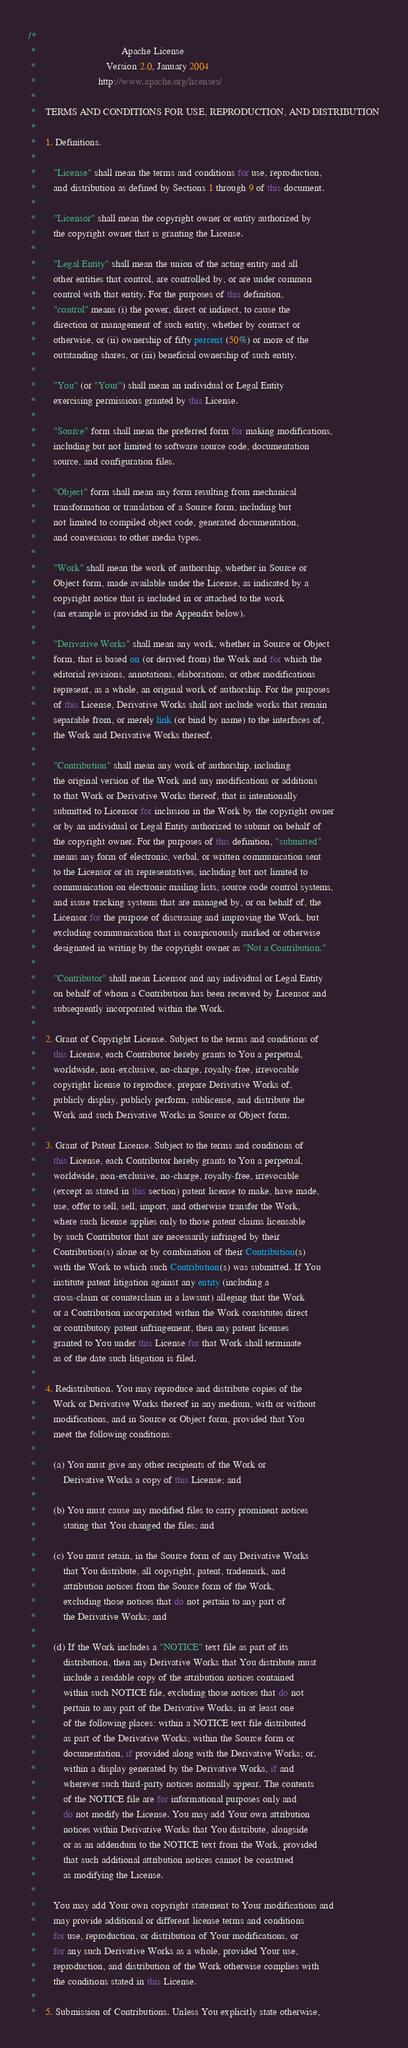<code> <loc_0><loc_0><loc_500><loc_500><_Java_>/*
 *                                  Apache License
 *                            Version 2.0, January 2004
 *                         http://www.apache.org/licenses/
 *
 *    TERMS AND CONDITIONS FOR USE, REPRODUCTION, AND DISTRIBUTION
 *
 *    1. Definitions.
 *
 *       "License" shall mean the terms and conditions for use, reproduction,
 *       and distribution as defined by Sections 1 through 9 of this document.
 *
 *       "Licensor" shall mean the copyright owner or entity authorized by
 *       the copyright owner that is granting the License.
 *
 *       "Legal Entity" shall mean the union of the acting entity and all
 *       other entities that control, are controlled by, or are under common
 *       control with that entity. For the purposes of this definition,
 *       "control" means (i) the power, direct or indirect, to cause the
 *       direction or management of such entity, whether by contract or
 *       otherwise, or (ii) ownership of fifty percent (50%) or more of the
 *       outstanding shares, or (iii) beneficial ownership of such entity.
 *
 *       "You" (or "Your") shall mean an individual or Legal Entity
 *       exercising permissions granted by this License.
 *
 *       "Source" form shall mean the preferred form for making modifications,
 *       including but not limited to software source code, documentation
 *       source, and configuration files.
 *
 *       "Object" form shall mean any form resulting from mechanical
 *       transformation or translation of a Source form, including but
 *       not limited to compiled object code, generated documentation,
 *       and conversions to other media types.
 *
 *       "Work" shall mean the work of authorship, whether in Source or
 *       Object form, made available under the License, as indicated by a
 *       copyright notice that is included in or attached to the work
 *       (an example is provided in the Appendix below).
 *
 *       "Derivative Works" shall mean any work, whether in Source or Object
 *       form, that is based on (or derived from) the Work and for which the
 *       editorial revisions, annotations, elaborations, or other modifications
 *       represent, as a whole, an original work of authorship. For the purposes
 *       of this License, Derivative Works shall not include works that remain
 *       separable from, or merely link (or bind by name) to the interfaces of,
 *       the Work and Derivative Works thereof.
 *
 *       "Contribution" shall mean any work of authorship, including
 *       the original version of the Work and any modifications or additions
 *       to that Work or Derivative Works thereof, that is intentionally
 *       submitted to Licensor for inclusion in the Work by the copyright owner
 *       or by an individual or Legal Entity authorized to submit on behalf of
 *       the copyright owner. For the purposes of this definition, "submitted"
 *       means any form of electronic, verbal, or written communication sent
 *       to the Licensor or its representatives, including but not limited to
 *       communication on electronic mailing lists, source code control systems,
 *       and issue tracking systems that are managed by, or on behalf of, the
 *       Licensor for the purpose of discussing and improving the Work, but
 *       excluding communication that is conspicuously marked or otherwise
 *       designated in writing by the copyright owner as "Not a Contribution."
 *
 *       "Contributor" shall mean Licensor and any individual or Legal Entity
 *       on behalf of whom a Contribution has been received by Licensor and
 *       subsequently incorporated within the Work.
 *
 *    2. Grant of Copyright License. Subject to the terms and conditions of
 *       this License, each Contributor hereby grants to You a perpetual,
 *       worldwide, non-exclusive, no-charge, royalty-free, irrevocable
 *       copyright license to reproduce, prepare Derivative Works of,
 *       publicly display, publicly perform, sublicense, and distribute the
 *       Work and such Derivative Works in Source or Object form.
 *
 *    3. Grant of Patent License. Subject to the terms and conditions of
 *       this License, each Contributor hereby grants to You a perpetual,
 *       worldwide, non-exclusive, no-charge, royalty-free, irrevocable
 *       (except as stated in this section) patent license to make, have made,
 *       use, offer to sell, sell, import, and otherwise transfer the Work,
 *       where such license applies only to those patent claims licensable
 *       by such Contributor that are necessarily infringed by their
 *       Contribution(s) alone or by combination of their Contribution(s)
 *       with the Work to which such Contribution(s) was submitted. If You
 *       institute patent litigation against any entity (including a
 *       cross-claim or counterclaim in a lawsuit) alleging that the Work
 *       or a Contribution incorporated within the Work constitutes direct
 *       or contributory patent infringement, then any patent licenses
 *       granted to You under this License for that Work shall terminate
 *       as of the date such litigation is filed.
 *
 *    4. Redistribution. You may reproduce and distribute copies of the
 *       Work or Derivative Works thereof in any medium, with or without
 *       modifications, and in Source or Object form, provided that You
 *       meet the following conditions:
 *
 *       (a) You must give any other recipients of the Work or
 *           Derivative Works a copy of this License; and
 *
 *       (b) You must cause any modified files to carry prominent notices
 *           stating that You changed the files; and
 *
 *       (c) You must retain, in the Source form of any Derivative Works
 *           that You distribute, all copyright, patent, trademark, and
 *           attribution notices from the Source form of the Work,
 *           excluding those notices that do not pertain to any part of
 *           the Derivative Works; and
 *
 *       (d) If the Work includes a "NOTICE" text file as part of its
 *           distribution, then any Derivative Works that You distribute must
 *           include a readable copy of the attribution notices contained
 *           within such NOTICE file, excluding those notices that do not
 *           pertain to any part of the Derivative Works, in at least one
 *           of the following places: within a NOTICE text file distributed
 *           as part of the Derivative Works; within the Source form or
 *           documentation, if provided along with the Derivative Works; or,
 *           within a display generated by the Derivative Works, if and
 *           wherever such third-party notices normally appear. The contents
 *           of the NOTICE file are for informational purposes only and
 *           do not modify the License. You may add Your own attribution
 *           notices within Derivative Works that You distribute, alongside
 *           or as an addendum to the NOTICE text from the Work, provided
 *           that such additional attribution notices cannot be construed
 *           as modifying the License.
 *
 *       You may add Your own copyright statement to Your modifications and
 *       may provide additional or different license terms and conditions
 *       for use, reproduction, or distribution of Your modifications, or
 *       for any such Derivative Works as a whole, provided Your use,
 *       reproduction, and distribution of the Work otherwise complies with
 *       the conditions stated in this License.
 *
 *    5. Submission of Contributions. Unless You explicitly state otherwise,</code> 